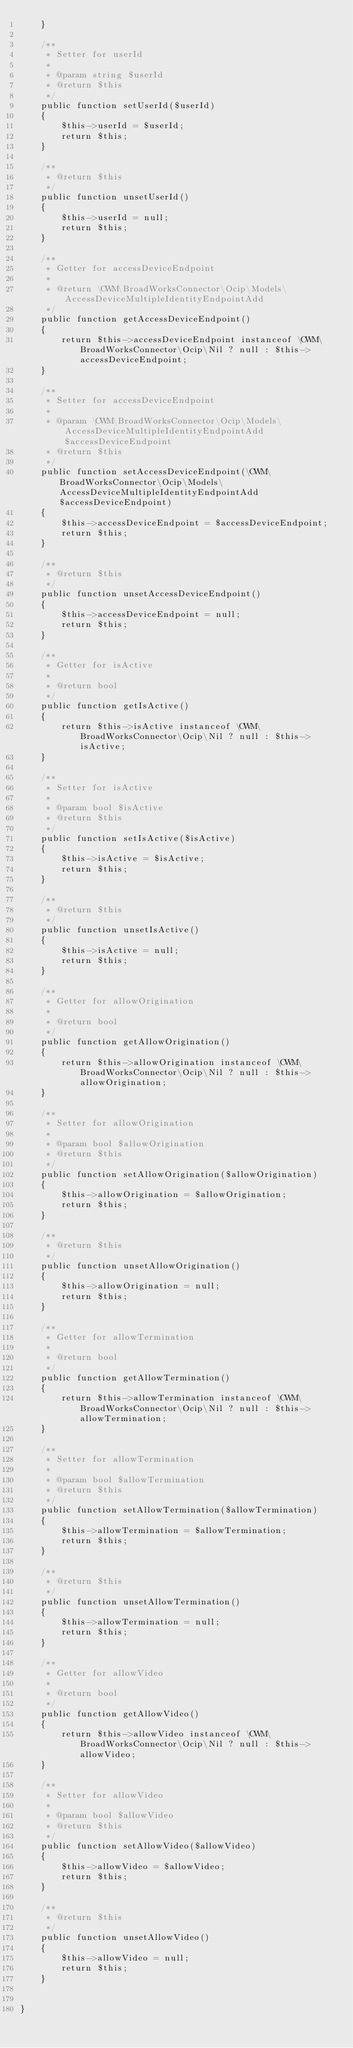Convert code to text. <code><loc_0><loc_0><loc_500><loc_500><_PHP_>    }

    /**
     * Setter for userId
     *
     * @param string $userId
     * @return $this
     */
    public function setUserId($userId)
    {
        $this->userId = $userId;
        return $this;
    }

    /**
     * @return $this
     */
    public function unsetUserId()
    {
        $this->userId = null;
        return $this;
    }

    /**
     * Getter for accessDeviceEndpoint
     *
     * @return \CWM\BroadWorksConnector\Ocip\Models\AccessDeviceMultipleIdentityEndpointAdd
     */
    public function getAccessDeviceEndpoint()
    {
        return $this->accessDeviceEndpoint instanceof \CWM\BroadWorksConnector\Ocip\Nil ? null : $this->accessDeviceEndpoint;
    }

    /**
     * Setter for accessDeviceEndpoint
     *
     * @param \CWM\BroadWorksConnector\Ocip\Models\AccessDeviceMultipleIdentityEndpointAdd $accessDeviceEndpoint
     * @return $this
     */
    public function setAccessDeviceEndpoint(\CWM\BroadWorksConnector\Ocip\Models\AccessDeviceMultipleIdentityEndpointAdd $accessDeviceEndpoint)
    {
        $this->accessDeviceEndpoint = $accessDeviceEndpoint;
        return $this;
    }

    /**
     * @return $this
     */
    public function unsetAccessDeviceEndpoint()
    {
        $this->accessDeviceEndpoint = null;
        return $this;
    }

    /**
     * Getter for isActive
     *
     * @return bool
     */
    public function getIsActive()
    {
        return $this->isActive instanceof \CWM\BroadWorksConnector\Ocip\Nil ? null : $this->isActive;
    }

    /**
     * Setter for isActive
     *
     * @param bool $isActive
     * @return $this
     */
    public function setIsActive($isActive)
    {
        $this->isActive = $isActive;
        return $this;
    }

    /**
     * @return $this
     */
    public function unsetIsActive()
    {
        $this->isActive = null;
        return $this;
    }

    /**
     * Getter for allowOrigination
     *
     * @return bool
     */
    public function getAllowOrigination()
    {
        return $this->allowOrigination instanceof \CWM\BroadWorksConnector\Ocip\Nil ? null : $this->allowOrigination;
    }

    /**
     * Setter for allowOrigination
     *
     * @param bool $allowOrigination
     * @return $this
     */
    public function setAllowOrigination($allowOrigination)
    {
        $this->allowOrigination = $allowOrigination;
        return $this;
    }

    /**
     * @return $this
     */
    public function unsetAllowOrigination()
    {
        $this->allowOrigination = null;
        return $this;
    }

    /**
     * Getter for allowTermination
     *
     * @return bool
     */
    public function getAllowTermination()
    {
        return $this->allowTermination instanceof \CWM\BroadWorksConnector\Ocip\Nil ? null : $this->allowTermination;
    }

    /**
     * Setter for allowTermination
     *
     * @param bool $allowTermination
     * @return $this
     */
    public function setAllowTermination($allowTermination)
    {
        $this->allowTermination = $allowTermination;
        return $this;
    }

    /**
     * @return $this
     */
    public function unsetAllowTermination()
    {
        $this->allowTermination = null;
        return $this;
    }

    /**
     * Getter for allowVideo
     *
     * @return bool
     */
    public function getAllowVideo()
    {
        return $this->allowVideo instanceof \CWM\BroadWorksConnector\Ocip\Nil ? null : $this->allowVideo;
    }

    /**
     * Setter for allowVideo
     *
     * @param bool $allowVideo
     * @return $this
     */
    public function setAllowVideo($allowVideo)
    {
        $this->allowVideo = $allowVideo;
        return $this;
    }

    /**
     * @return $this
     */
    public function unsetAllowVideo()
    {
        $this->allowVideo = null;
        return $this;
    }


}

</code> 